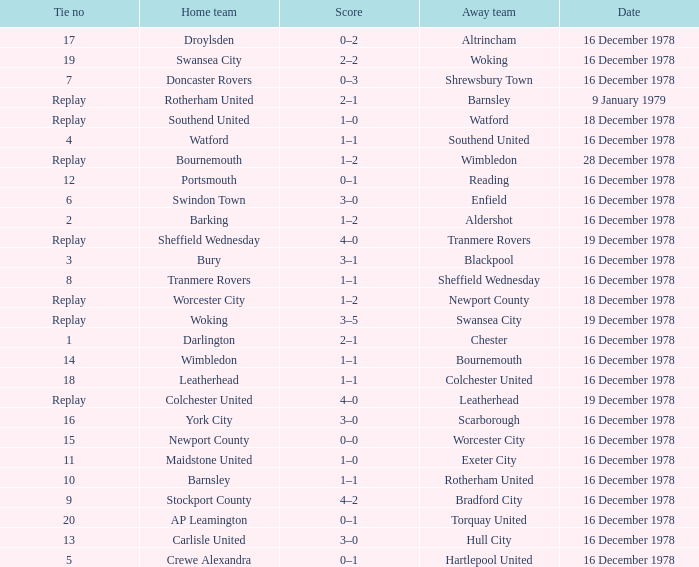What is the score for the date of 16 december 1978, with a tie no of 9? 4–2. 